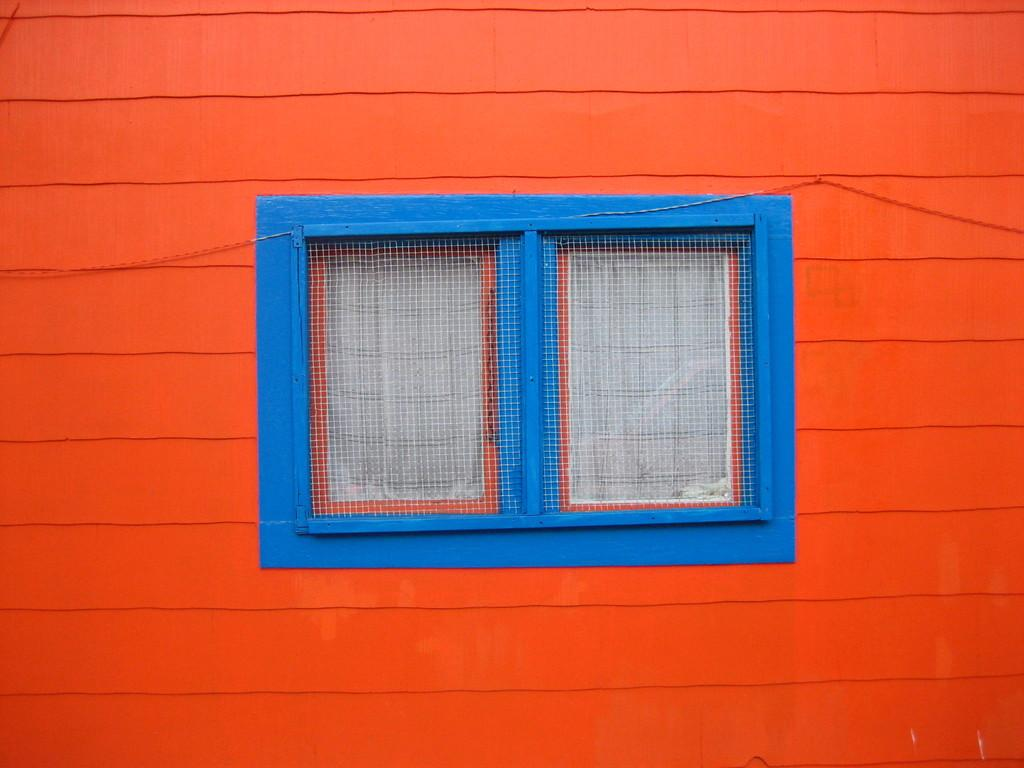What type of opening is present in the image? There is a window with doors in the image. What is attached to the window? There is a mesh attached to the window. What part of a building can be seen in the image? The image appears to show a building wall. What color is the building wall? The building wall is orange in color. What type of cable can be seen running along the building wall in the image? There is no cable visible in the image; it only shows a window with doors, a mesh, and an orange building wall. 